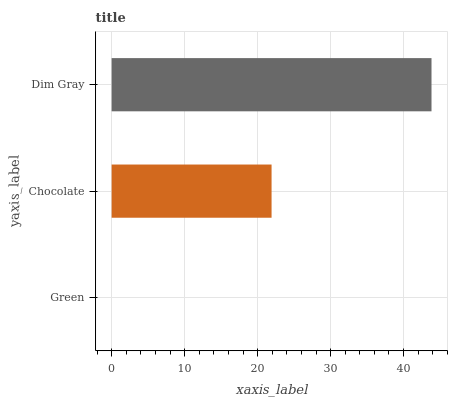Is Green the minimum?
Answer yes or no. Yes. Is Dim Gray the maximum?
Answer yes or no. Yes. Is Chocolate the minimum?
Answer yes or no. No. Is Chocolate the maximum?
Answer yes or no. No. Is Chocolate greater than Green?
Answer yes or no. Yes. Is Green less than Chocolate?
Answer yes or no. Yes. Is Green greater than Chocolate?
Answer yes or no. No. Is Chocolate less than Green?
Answer yes or no. No. Is Chocolate the high median?
Answer yes or no. Yes. Is Chocolate the low median?
Answer yes or no. Yes. Is Dim Gray the high median?
Answer yes or no. No. Is Green the low median?
Answer yes or no. No. 